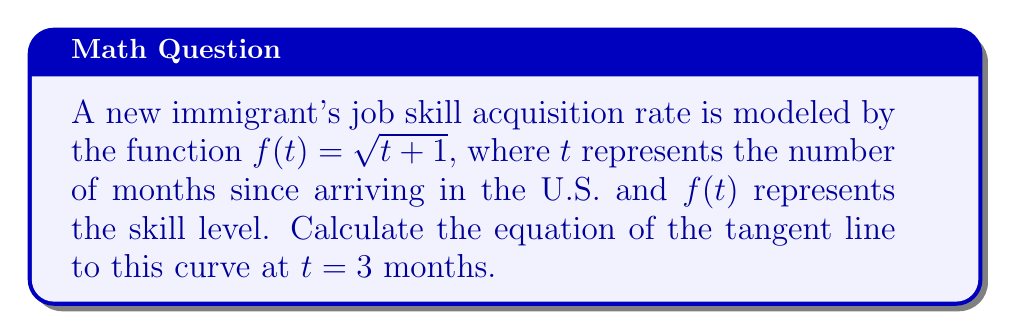Could you help me with this problem? To find the equation of the tangent line, we need to follow these steps:

1) The general equation of a tangent line is $y = mx + b$, where $m$ is the slope (derivative at the point) and $b$ is the y-intercept.

2) First, let's find the derivative of $f(t)$:
   $f(t) = \sqrt{t+1} = (t+1)^{\frac{1}{2}}$
   $f'(t) = \frac{1}{2}(t+1)^{-\frac{1}{2}} = \frac{1}{2\sqrt{t+1}}$

3) Now, we need to find the slope at $t = 3$:
   $m = f'(3) = \frac{1}{2\sqrt{3+1}} = \frac{1}{2\sqrt{4}} = \frac{1}{4}$

4) Next, we need to find the y-coordinate of the point on the curve at $t = 3$:
   $f(3) = \sqrt{3+1} = \sqrt{4} = 2$

5) Now we have a point $(3, 2)$ and the slope $\frac{1}{4}$. We can use the point-slope form of a line:
   $y - y_1 = m(x - x_1)$
   $y - 2 = \frac{1}{4}(x - 3)$

6) Simplify to slope-intercept form:
   $y = \frac{1}{4}x - \frac{3}{4} + 2$
   $y = \frac{1}{4}x + \frac{5}{4}$

Therefore, the equation of the tangent line is $y = \frac{1}{4}x + \frac{5}{4}$.
Answer: $y = \frac{1}{4}x + \frac{5}{4}$ 